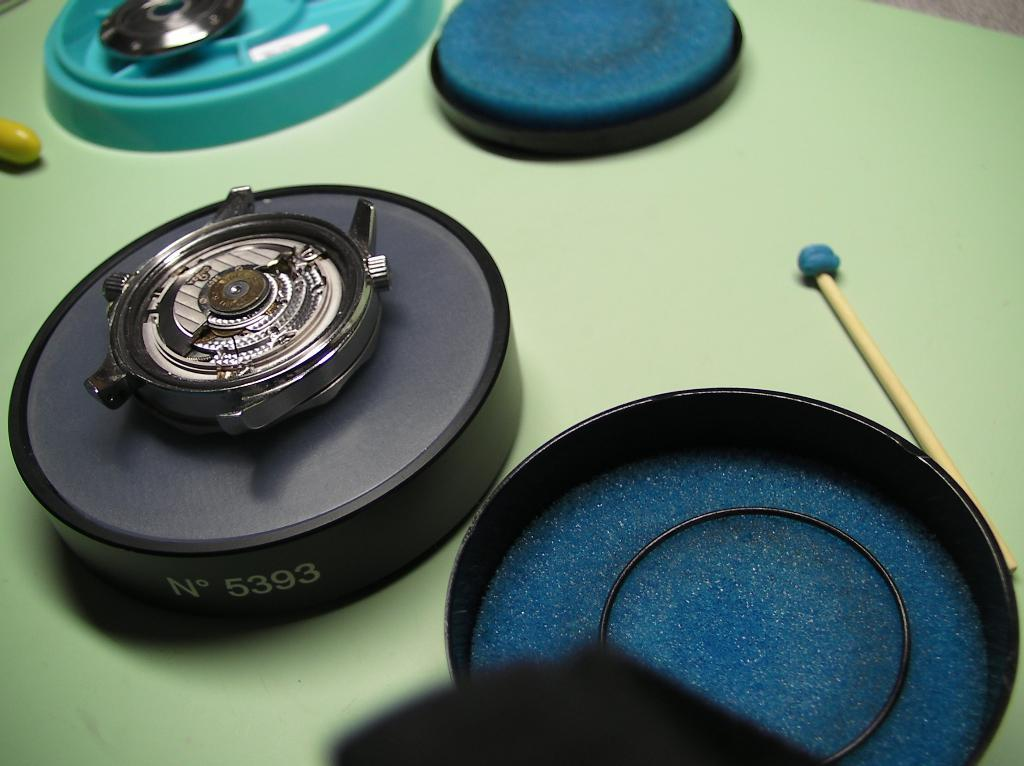<image>
Describe the image concisely. A black disk has "N 5393" on the side. 